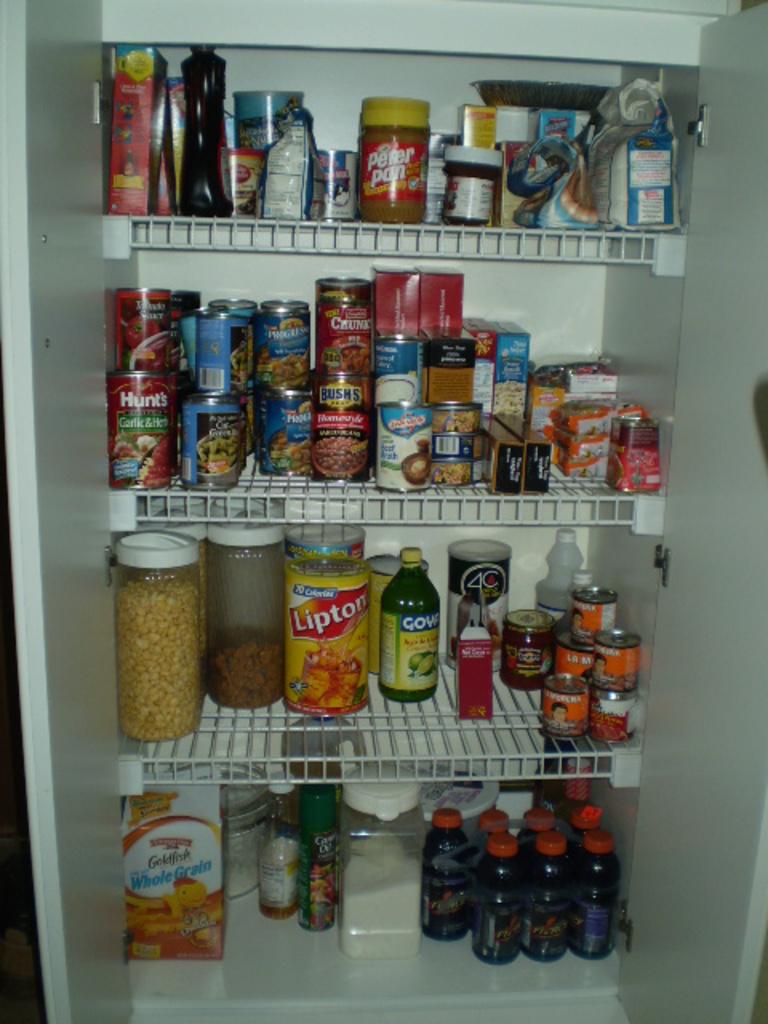What brand of tea is in the fridge?
Your answer should be very brief. Lipton. What kind of crackers are on the bottom left?
Your answer should be compact. Goldfish. 